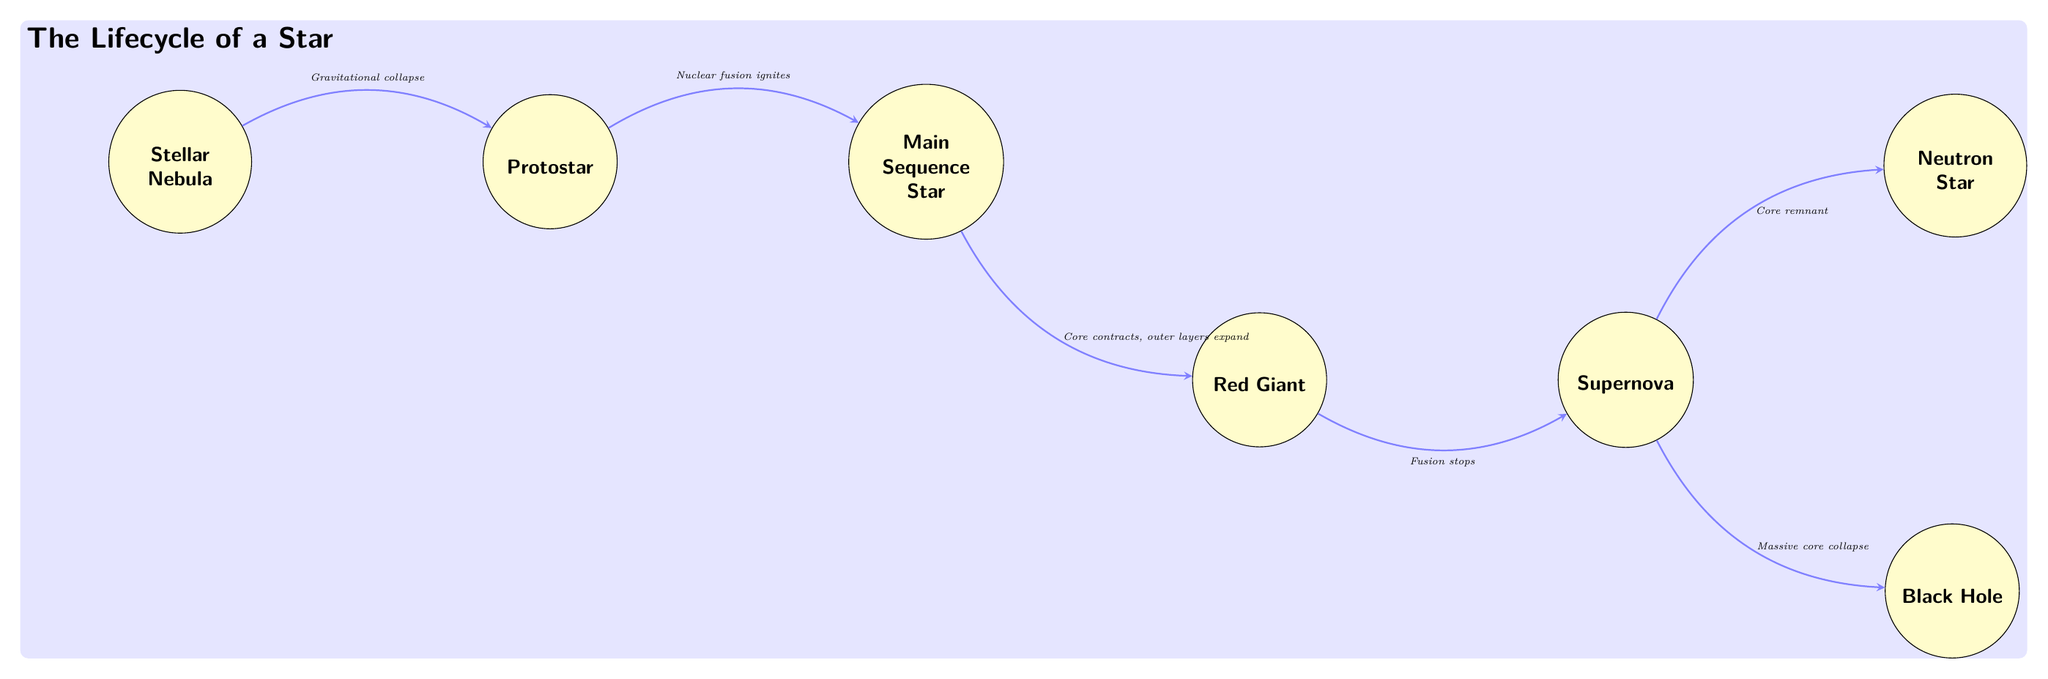What is the first stage in the lifecycle of a star? The diagram indicates that the first stage in the lifecycle of a star is the "Stellar Nebula," which is shown on the far left of the diagram.
Answer: Stellar Nebula What follows a protostar in the lifecycle? According to the diagram, the stage that follows the protostar is the "Main Sequence Star," which is directly to the right of the protostar node.
Answer: Main Sequence Star What happens after a red giant? The diagram details that the next stage after the red giant is the "Supernova," which is connected by an arrow labeled "Fusion stops."
Answer: Supernova How many end points are shown in the diagram? The diagram features two potential end points for a star: "Neutron Star" and "Black Hole," which appear below and above right of the supernova, respectively. Thus, there are two distinct outcomes depicted.
Answer: 2 What process leads from a nebula to a protostar? The diagram specifies the process as "Gravitational collapse," indicated by the arrow connecting the "Stellar Nebula" to the "Protostar."
Answer: Gravitational collapse What is produced in a supernova? The diagram shows that the supernova results in either a "Neutron Star" or a "Black Hole," which are connected to the supernova by the arrows "Core remnant" and "Massive core collapse," respectively.
Answer: Neutron Star or Black Hole Which stage is marked by the sun icon? In the lifecycle diagram, the stage marked by the sun icon is the "Main Sequence Star," which is located between the protostar and the red giant.
Answer: Main Sequence Star What is the central process that ignites a protostar? The diagram indicates that the process that ignites a protostar is "Nuclear fusion ignites," as shown by the label between the protostar and the main sequence star.
Answer: Nuclear fusion ignites 